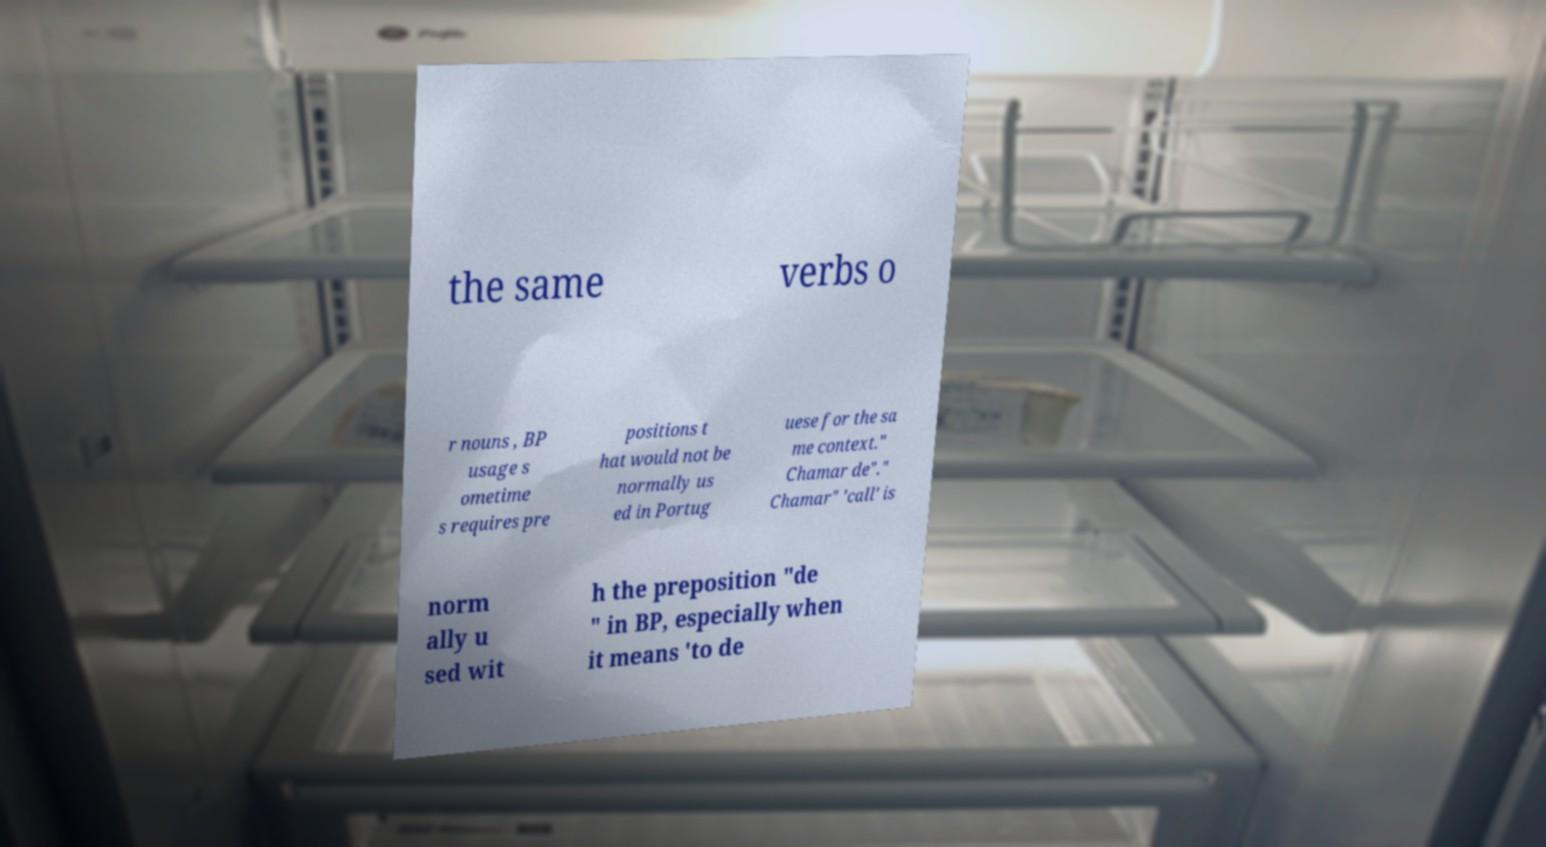Please identify and transcribe the text found in this image. the same verbs o r nouns , BP usage s ometime s requires pre positions t hat would not be normally us ed in Portug uese for the sa me context." Chamar de"." Chamar" 'call' is norm ally u sed wit h the preposition "de " in BP, especially when it means 'to de 